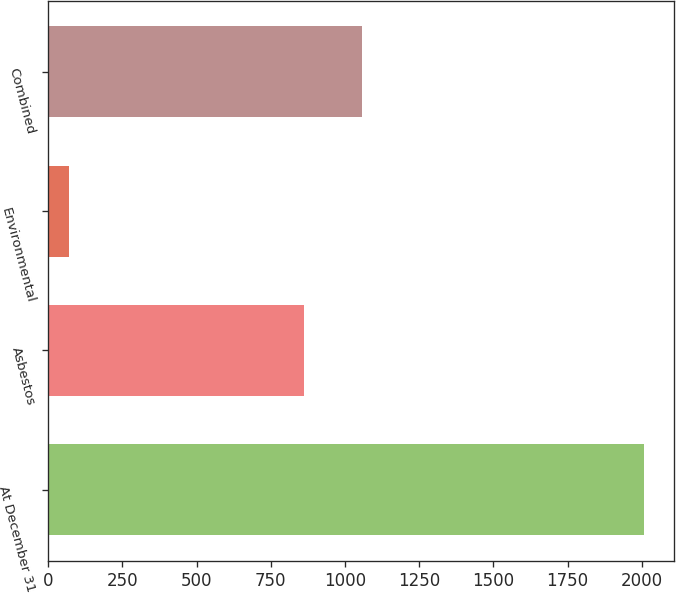Convert chart to OTSL. <chart><loc_0><loc_0><loc_500><loc_500><bar_chart><fcel>At December 31<fcel>Asbestos<fcel>Environmental<fcel>Combined<nl><fcel>2009<fcel>863<fcel>71<fcel>1056.8<nl></chart> 